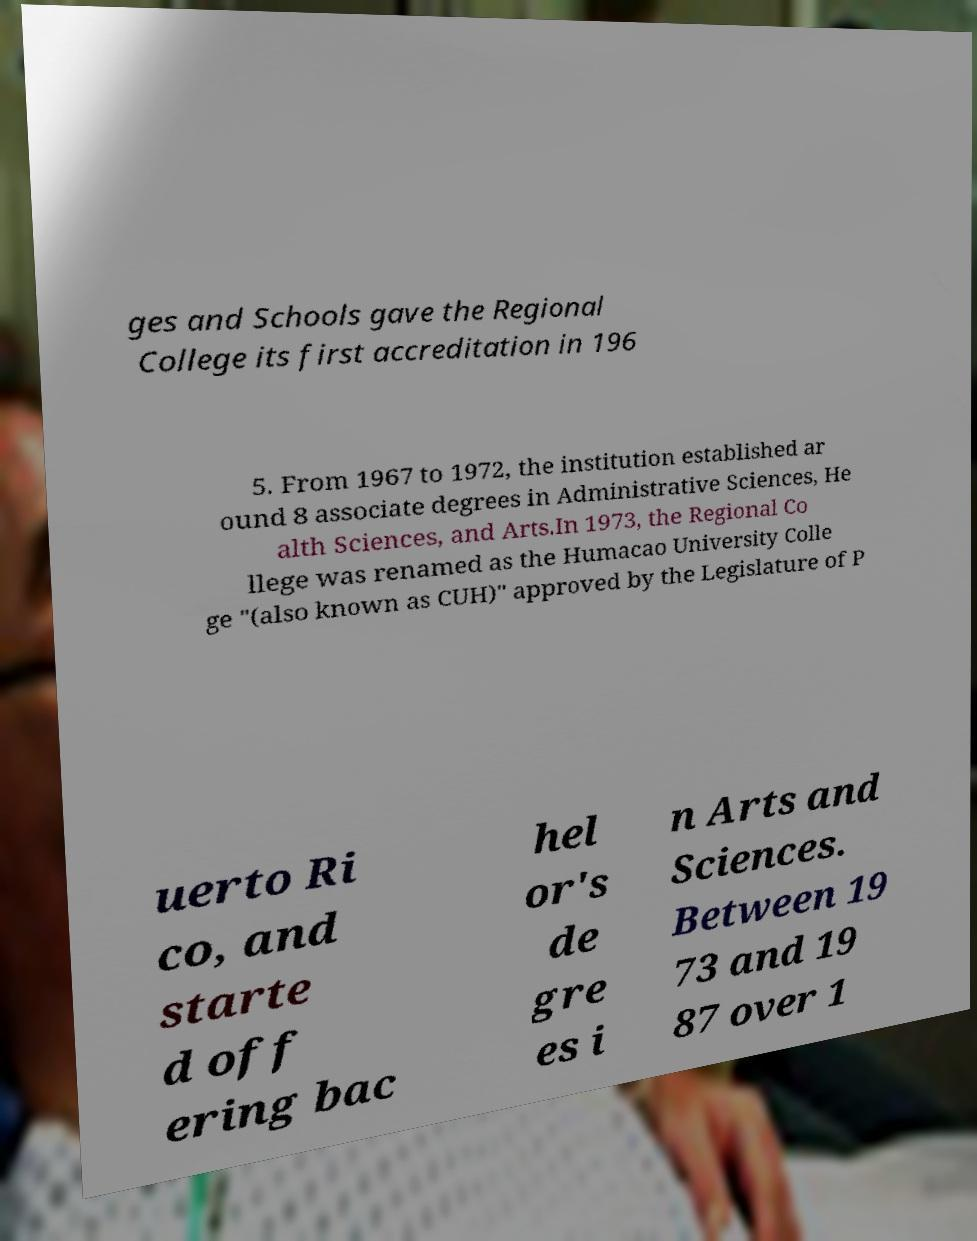What messages or text are displayed in this image? I need them in a readable, typed format. ges and Schools gave the Regional College its first accreditation in 196 5. From 1967 to 1972, the institution established ar ound 8 associate degrees in Administrative Sciences, He alth Sciences, and Arts.In 1973, the Regional Co llege was renamed as the Humacao University Colle ge "(also known as CUH)" approved by the Legislature of P uerto Ri co, and starte d off ering bac hel or's de gre es i n Arts and Sciences. Between 19 73 and 19 87 over 1 